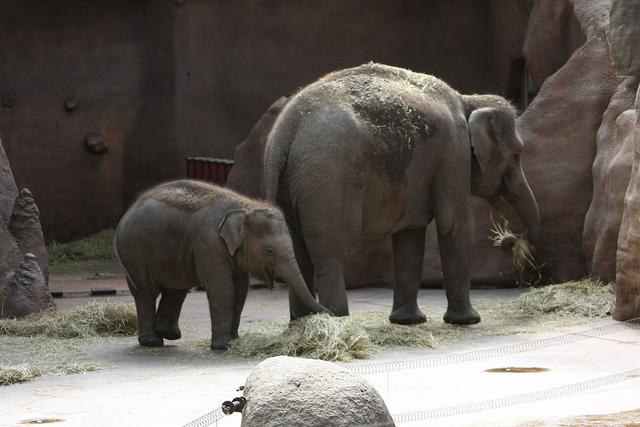How many elephants are there?
Concise answer only. 2. Is the small elephant picking up the hay?
Keep it brief. Yes. Do elephants normally eat hay?
Answer briefly. Yes. 